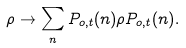Convert formula to latex. <formula><loc_0><loc_0><loc_500><loc_500>\rho \rightarrow \sum _ { n } P _ { o , t } ( n ) \rho P _ { o , t } ( n ) .</formula> 